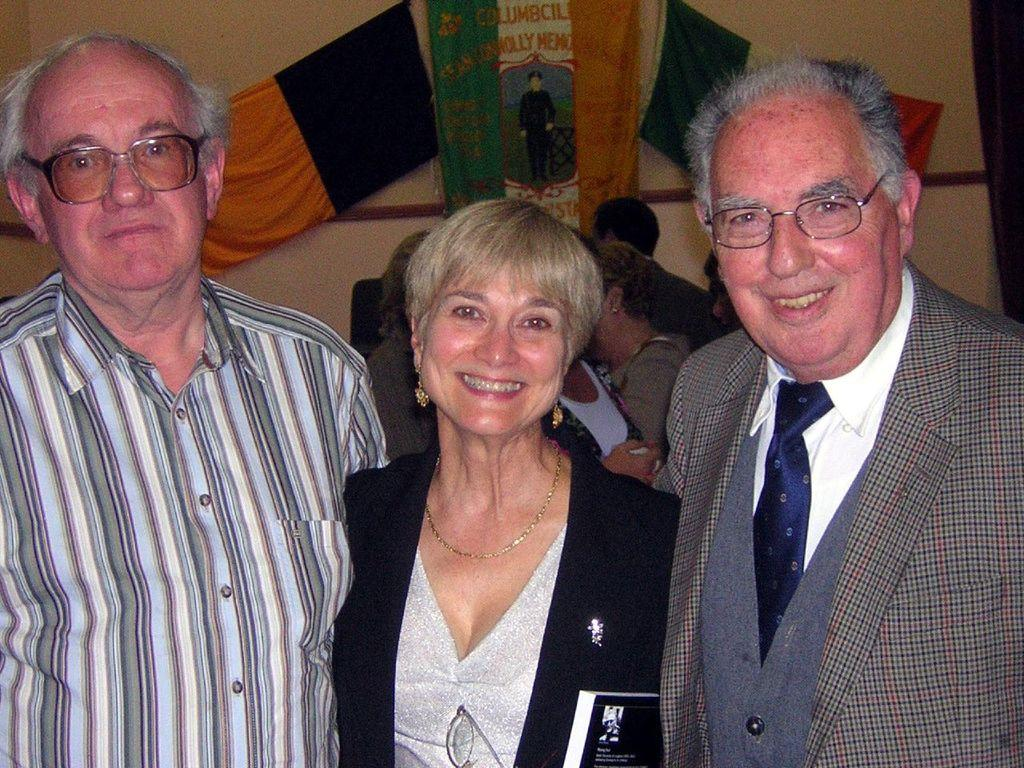How many people are present in the image? There are three people in the image. What are the people in the image doing? The people are seeing and smiling. What can be seen in the background of the image? There is a wall and flags in the background of the image. Are there any other people visible in the image? Yes, there is a group of people in the background of the image. What type of shelf can be seen in the image? There is no shelf present in the image. What school event might be taking place in the image? The image does not provide any information about a school event or location. 